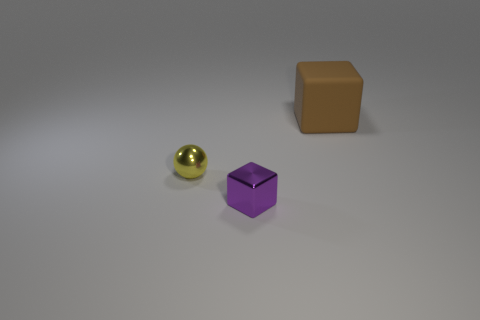Add 1 tiny cyan things. How many objects exist? 4 Subtract all spheres. How many objects are left? 2 Subtract all small blue metal blocks. Subtract all rubber blocks. How many objects are left? 2 Add 1 brown rubber cubes. How many brown rubber cubes are left? 2 Add 3 small purple metallic objects. How many small purple metallic objects exist? 4 Subtract 0 green spheres. How many objects are left? 3 